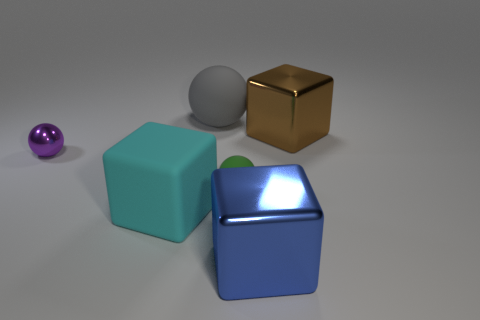Subtract 1 cubes. How many cubes are left? 2 Subtract all matte balls. How many balls are left? 1 Add 2 gray metal balls. How many objects exist? 8 Subtract all gray rubber objects. Subtract all gray rubber objects. How many objects are left? 4 Add 4 large cyan objects. How many large cyan objects are left? 5 Add 3 large yellow cylinders. How many large yellow cylinders exist? 3 Subtract 0 yellow spheres. How many objects are left? 6 